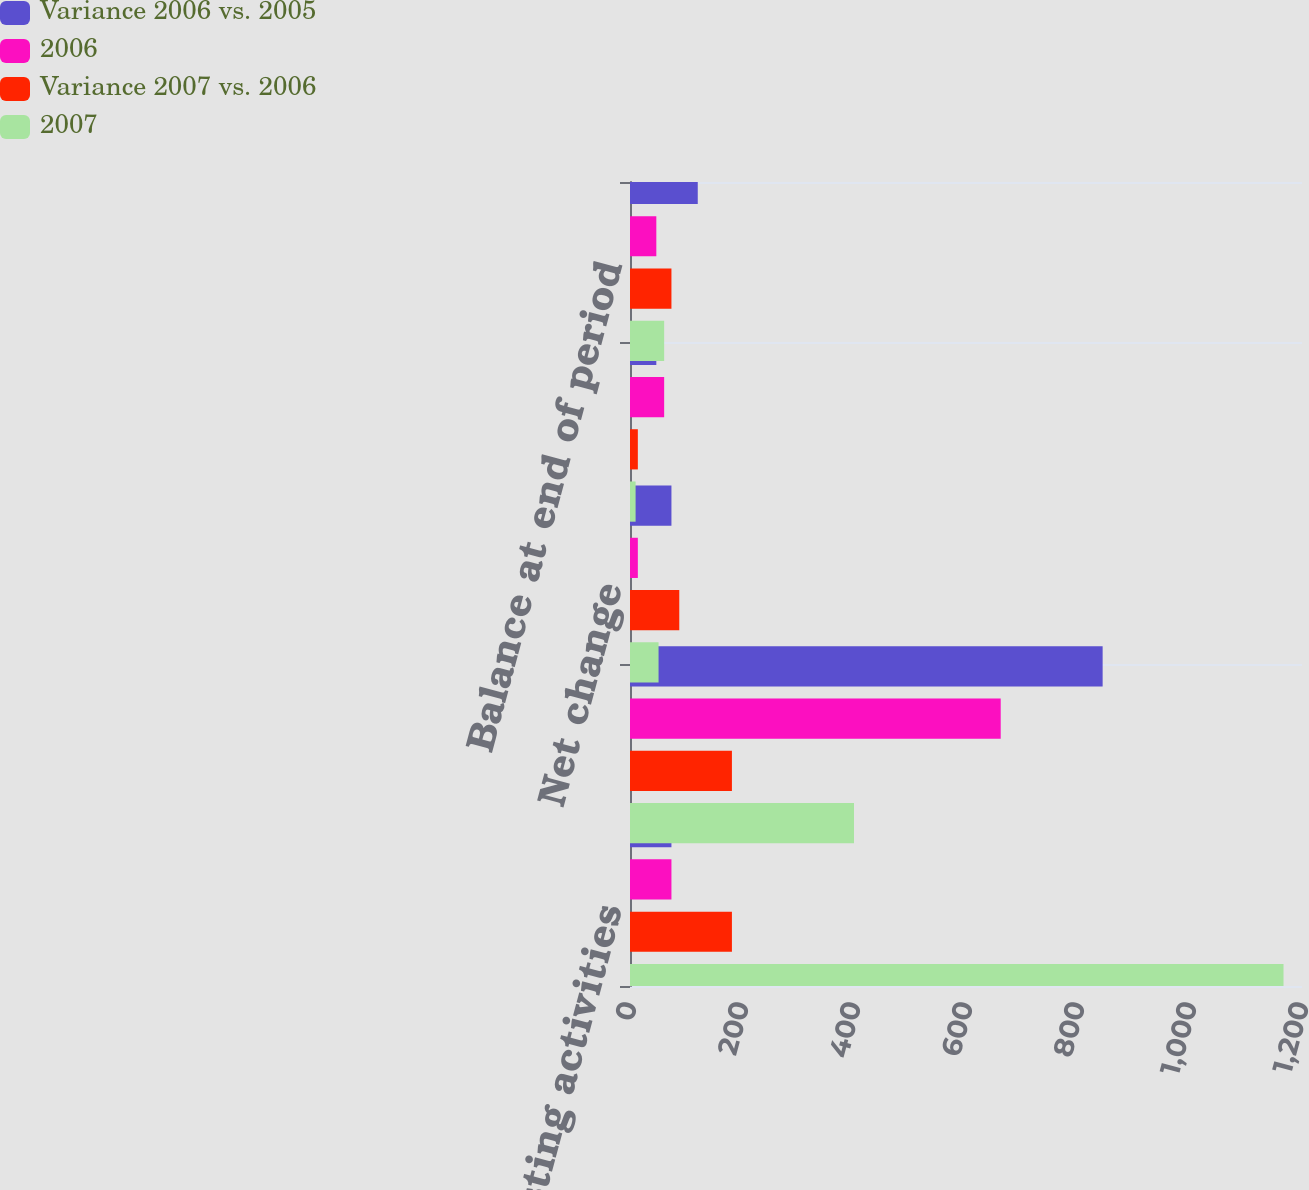Convert chart. <chart><loc_0><loc_0><loc_500><loc_500><stacked_bar_chart><ecel><fcel>Investing activities<fcel>Financing activities<fcel>Net change<fcel>Balance at beginning of period<fcel>Balance at end of period<nl><fcel>Variance 2006 vs. 2005<fcel>74<fcel>844<fcel>74<fcel>47<fcel>121<nl><fcel>2006<fcel>74<fcel>662<fcel>14<fcel>61<fcel>47<nl><fcel>Variance 2007 vs. 2006<fcel>182<fcel>182<fcel>88<fcel>14<fcel>74<nl><fcel>2007<fcel>1167<fcel>400<fcel>51<fcel>10<fcel>61<nl></chart> 